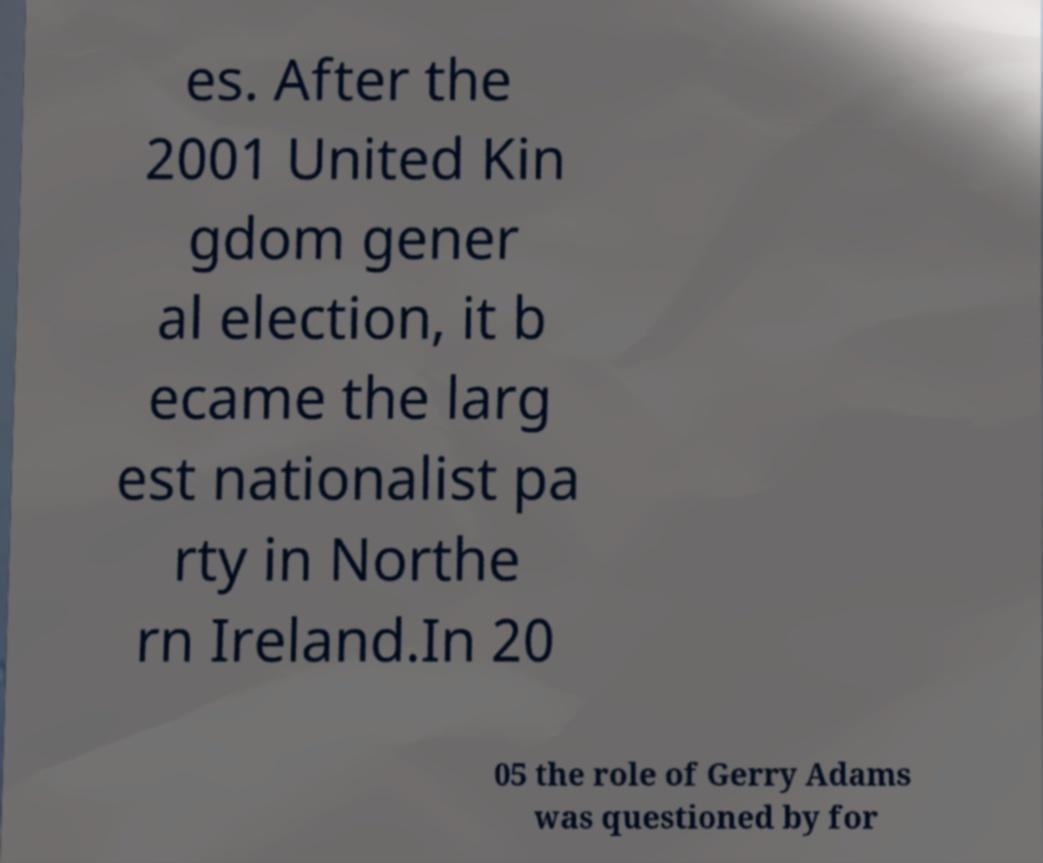I need the written content from this picture converted into text. Can you do that? es. After the 2001 United Kin gdom gener al election, it b ecame the larg est nationalist pa rty in Northe rn Ireland.In 20 05 the role of Gerry Adams was questioned by for 